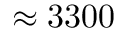<formula> <loc_0><loc_0><loc_500><loc_500>\approx 3 3 0 0</formula> 